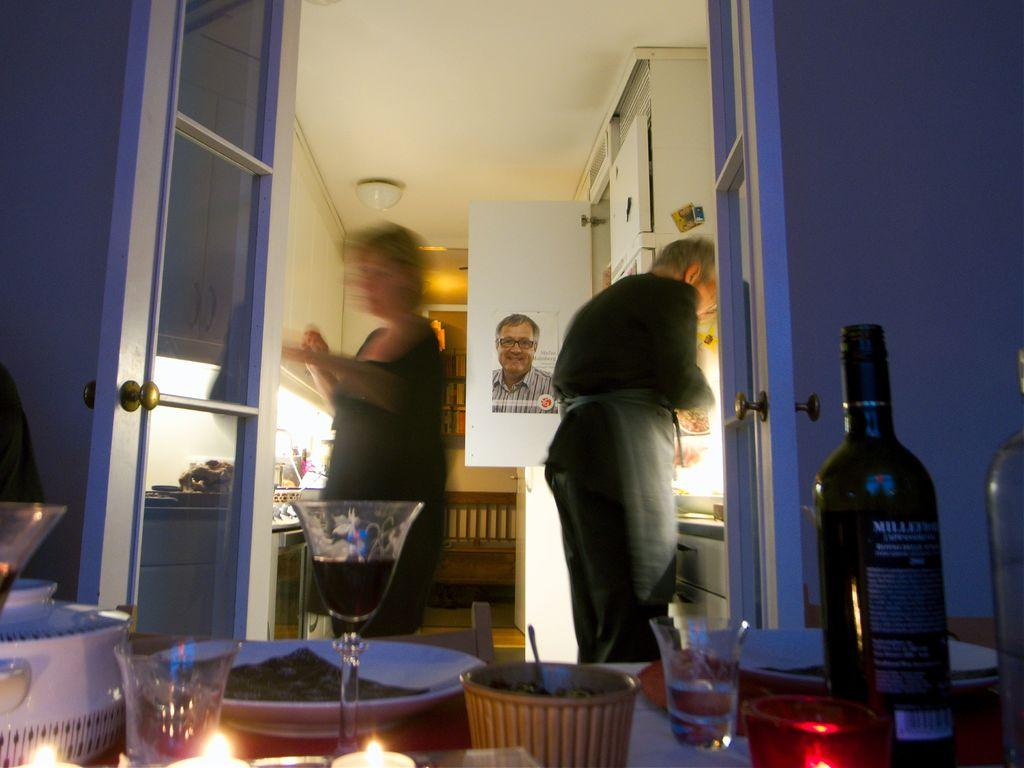How many people are in the image? There are two persons standing in the image. What can be seen in the foreground of the image? There are objects in the foreground of the image. What is visible in the background of the image? There is a roof of a building, a door, and a refrigerator in the background of the image. What type of berry is being used as a prop in the story depicted in the image? There is no story or berry present in the image. 